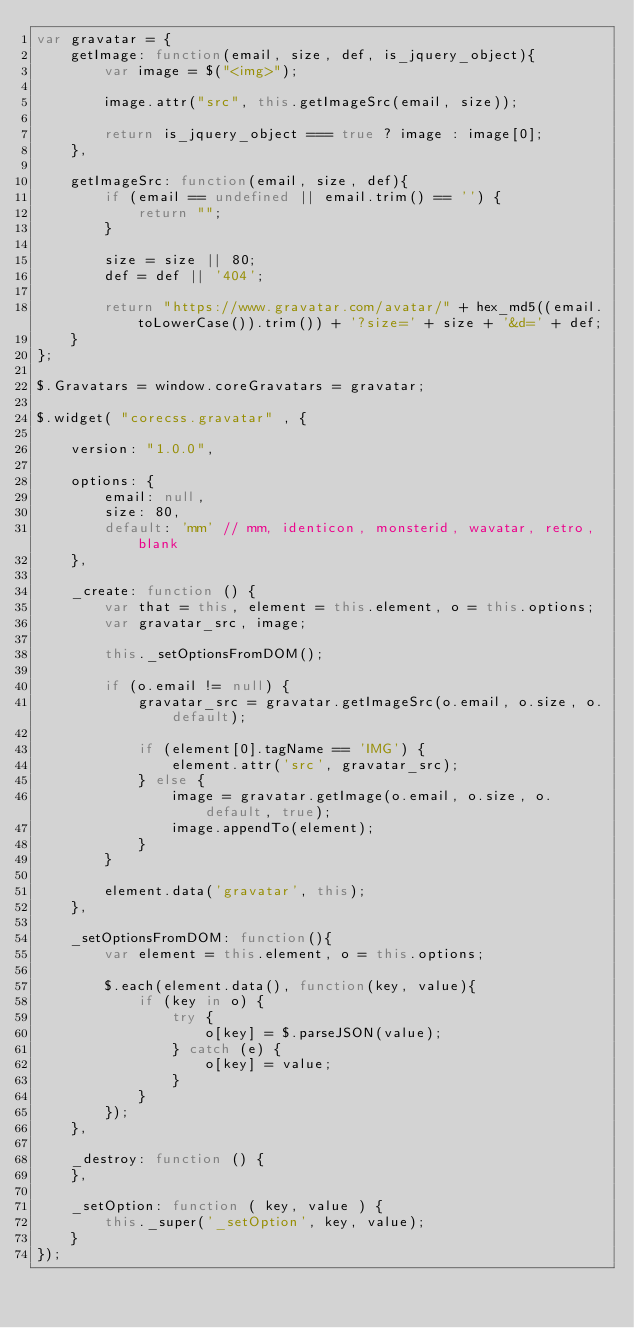<code> <loc_0><loc_0><loc_500><loc_500><_JavaScript_>var gravatar = {
    getImage: function(email, size, def, is_jquery_object){
        var image = $("<img>");

        image.attr("src", this.getImageSrc(email, size));

        return is_jquery_object === true ? image : image[0];
    },

    getImageSrc: function(email, size, def){
        if (email == undefined || email.trim() == '') {
            return "";
        }

        size = size || 80;
        def = def || '404';

        return "https://www.gravatar.com/avatar/" + hex_md5((email.toLowerCase()).trim()) + '?size=' + size + '&d=' + def;
    }
};

$.Gravatars = window.coreGravatars = gravatar;

$.widget( "corecss.gravatar" , {

    version: "1.0.0",

    options: {
        email: null,
        size: 80,
        default: 'mm' // mm, identicon, monsterid, wavatar, retro, blank
    },

    _create: function () {
        var that = this, element = this.element, o = this.options;
        var gravatar_src, image;

        this._setOptionsFromDOM();

        if (o.email != null) {
            gravatar_src = gravatar.getImageSrc(o.email, o.size, o.default);

            if (element[0].tagName == 'IMG') {
                element.attr('src', gravatar_src);
            } else {
                image = gravatar.getImage(o.email, o.size, o.default, true);
                image.appendTo(element);
            }
        }

        element.data('gravatar', this);
    },

    _setOptionsFromDOM: function(){
        var element = this.element, o = this.options;

        $.each(element.data(), function(key, value){
            if (key in o) {
                try {
                    o[key] = $.parseJSON(value);
                } catch (e) {
                    o[key] = value;
                }
            }
        });
    },

    _destroy: function () {
    },

    _setOption: function ( key, value ) {
        this._super('_setOption', key, value);
    }
});
</code> 